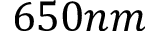Convert formula to latex. <formula><loc_0><loc_0><loc_500><loc_500>6 5 0 n m</formula> 